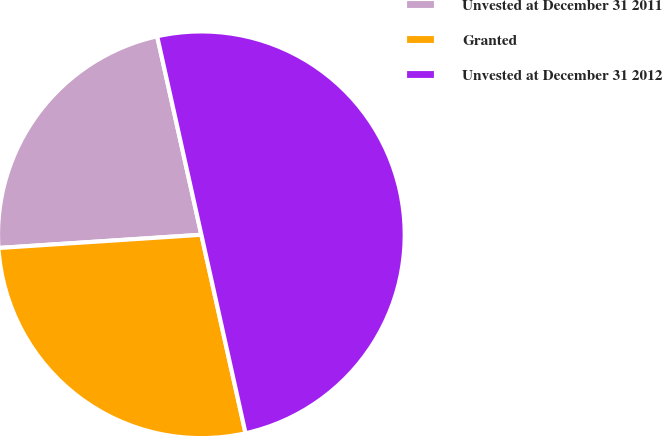<chart> <loc_0><loc_0><loc_500><loc_500><pie_chart><fcel>Unvested at December 31 2011<fcel>Granted<fcel>Unvested at December 31 2012<nl><fcel>22.55%<fcel>27.45%<fcel>50.0%<nl></chart> 